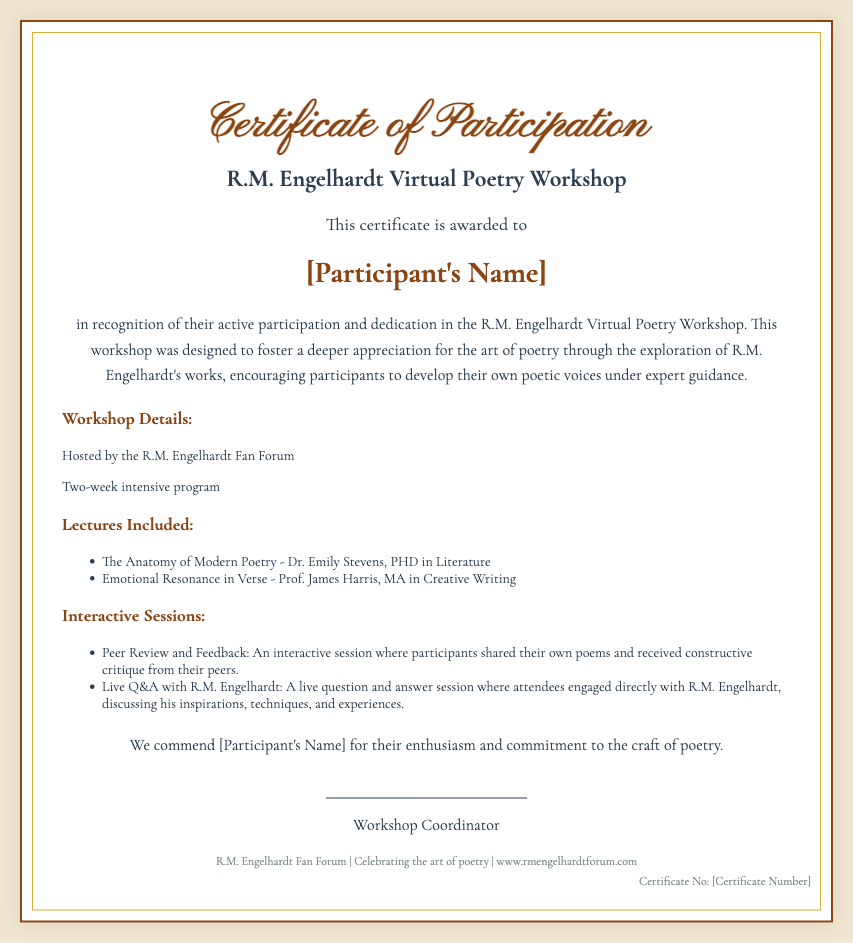What is the name of the workshop? The workshop is titled "R.M. Engelhardt Virtual Poetry Workshop."
Answer: R.M. Engelhardt Virtual Poetry Workshop Who is awarded the certificate? The certificate is awarded to the participant whose name will be provided.
Answer: [Participant's Name] How long was the workshop? The document states that it was a two-week intensive program.
Answer: Two-week Who hosted the workshop? The hosting entity for the workshop is mentioned in the document.
Answer: R.M. Engelhardt Fan Forum What is the main focus of the workshop? The workshop aims to foster appreciation for the art of poetry through exploration of R.M. Engelhardt's works.
Answer: Appreciation for poetry How many lectures are included in the workshop? The document lists two lectures included in the workshop.
Answer: Two What is the signature line for? The signature line is for the workshop coordinator's name.
Answer: Workshop Coordinator What is the website mentioned in the document? The footer of the certificate provides the website of the R.M. Engelhardt Fan Forum.
Answer: www.rmengelhardtforum.com What type of session included direct engagement with R.M. Engelhardt? The document mentions a live Q&A session.
Answer: Live Q&A 